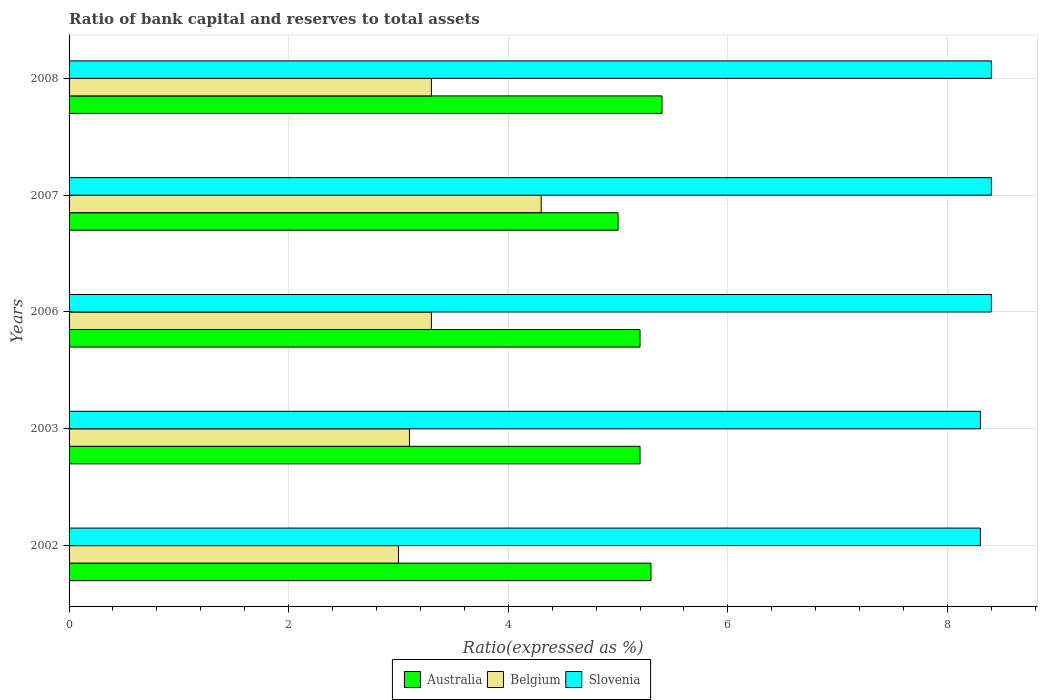How many groups of bars are there?
Provide a succinct answer. 5. Are the number of bars on each tick of the Y-axis equal?
Ensure brevity in your answer.  Yes. How many bars are there on the 3rd tick from the top?
Ensure brevity in your answer.  3. How many bars are there on the 1st tick from the bottom?
Your answer should be very brief. 3. What is the label of the 4th group of bars from the top?
Offer a terse response. 2003. Across all years, what is the maximum ratio of bank capital and reserves to total assets in Belgium?
Offer a terse response. 4.3. Across all years, what is the minimum ratio of bank capital and reserves to total assets in Belgium?
Your response must be concise. 3. In which year was the ratio of bank capital and reserves to total assets in Belgium maximum?
Give a very brief answer. 2007. What is the difference between the ratio of bank capital and reserves to total assets in Australia in 2002 and that in 2006?
Ensure brevity in your answer.  0.1. What is the difference between the ratio of bank capital and reserves to total assets in Slovenia in 2003 and the ratio of bank capital and reserves to total assets in Australia in 2002?
Ensure brevity in your answer.  3. What is the average ratio of bank capital and reserves to total assets in Australia per year?
Keep it short and to the point. 5.22. What is the ratio of the ratio of bank capital and reserves to total assets in Belgium in 2007 to that in 2008?
Provide a succinct answer. 1.3. What is the difference between the highest and the lowest ratio of bank capital and reserves to total assets in Australia?
Your answer should be very brief. 0.4. Is the sum of the ratio of bank capital and reserves to total assets in Belgium in 2003 and 2006 greater than the maximum ratio of bank capital and reserves to total assets in Slovenia across all years?
Your answer should be very brief. No. What does the 3rd bar from the top in 2006 represents?
Give a very brief answer. Australia. What does the 3rd bar from the bottom in 2007 represents?
Keep it short and to the point. Slovenia. How many bars are there?
Your answer should be compact. 15. Does the graph contain any zero values?
Your response must be concise. No. What is the title of the graph?
Your response must be concise. Ratio of bank capital and reserves to total assets. What is the label or title of the X-axis?
Make the answer very short. Ratio(expressed as %). What is the label or title of the Y-axis?
Ensure brevity in your answer.  Years. What is the Ratio(expressed as %) of Slovenia in 2002?
Your answer should be very brief. 8.3. What is the Ratio(expressed as %) of Australia in 2003?
Give a very brief answer. 5.2. What is the Ratio(expressed as %) in Belgium in 2003?
Ensure brevity in your answer.  3.1. What is the Ratio(expressed as %) in Slovenia in 2003?
Keep it short and to the point. 8.3. What is the Ratio(expressed as %) of Australia in 2006?
Offer a terse response. 5.2. What is the Ratio(expressed as %) of Slovenia in 2006?
Offer a very short reply. 8.4. What is the Ratio(expressed as %) of Australia in 2007?
Offer a terse response. 5. What is the Ratio(expressed as %) in Australia in 2008?
Provide a succinct answer. 5.4. What is the Ratio(expressed as %) in Slovenia in 2008?
Make the answer very short. 8.4. Across all years, what is the minimum Ratio(expressed as %) in Slovenia?
Keep it short and to the point. 8.3. What is the total Ratio(expressed as %) of Australia in the graph?
Your answer should be compact. 26.1. What is the total Ratio(expressed as %) in Belgium in the graph?
Offer a very short reply. 17. What is the total Ratio(expressed as %) of Slovenia in the graph?
Offer a terse response. 41.8. What is the difference between the Ratio(expressed as %) of Australia in 2002 and that in 2003?
Ensure brevity in your answer.  0.1. What is the difference between the Ratio(expressed as %) of Slovenia in 2002 and that in 2003?
Give a very brief answer. 0. What is the difference between the Ratio(expressed as %) of Belgium in 2002 and that in 2006?
Give a very brief answer. -0.3. What is the difference between the Ratio(expressed as %) of Slovenia in 2002 and that in 2006?
Offer a terse response. -0.1. What is the difference between the Ratio(expressed as %) in Australia in 2002 and that in 2007?
Your response must be concise. 0.3. What is the difference between the Ratio(expressed as %) of Belgium in 2002 and that in 2007?
Offer a terse response. -1.3. What is the difference between the Ratio(expressed as %) of Slovenia in 2002 and that in 2007?
Provide a short and direct response. -0.1. What is the difference between the Ratio(expressed as %) in Australia in 2002 and that in 2008?
Give a very brief answer. -0.1. What is the difference between the Ratio(expressed as %) in Australia in 2003 and that in 2006?
Your answer should be compact. 0. What is the difference between the Ratio(expressed as %) of Slovenia in 2003 and that in 2006?
Offer a terse response. -0.1. What is the difference between the Ratio(expressed as %) in Belgium in 2003 and that in 2007?
Make the answer very short. -1.2. What is the difference between the Ratio(expressed as %) in Belgium in 2003 and that in 2008?
Provide a succinct answer. -0.2. What is the difference between the Ratio(expressed as %) in Slovenia in 2003 and that in 2008?
Offer a very short reply. -0.1. What is the difference between the Ratio(expressed as %) of Belgium in 2006 and that in 2007?
Ensure brevity in your answer.  -1. What is the difference between the Ratio(expressed as %) of Slovenia in 2006 and that in 2008?
Make the answer very short. 0. What is the difference between the Ratio(expressed as %) of Belgium in 2007 and that in 2008?
Provide a short and direct response. 1. What is the difference between the Ratio(expressed as %) of Slovenia in 2007 and that in 2008?
Provide a short and direct response. 0. What is the difference between the Ratio(expressed as %) in Australia in 2002 and the Ratio(expressed as %) in Belgium in 2003?
Your response must be concise. 2.2. What is the difference between the Ratio(expressed as %) of Belgium in 2002 and the Ratio(expressed as %) of Slovenia in 2003?
Keep it short and to the point. -5.3. What is the difference between the Ratio(expressed as %) in Australia in 2002 and the Ratio(expressed as %) in Belgium in 2007?
Make the answer very short. 1. What is the difference between the Ratio(expressed as %) in Australia in 2002 and the Ratio(expressed as %) in Slovenia in 2007?
Give a very brief answer. -3.1. What is the difference between the Ratio(expressed as %) in Belgium in 2002 and the Ratio(expressed as %) in Slovenia in 2007?
Offer a very short reply. -5.4. What is the difference between the Ratio(expressed as %) of Australia in 2002 and the Ratio(expressed as %) of Slovenia in 2008?
Keep it short and to the point. -3.1. What is the difference between the Ratio(expressed as %) of Australia in 2003 and the Ratio(expressed as %) of Belgium in 2007?
Your response must be concise. 0.9. What is the difference between the Ratio(expressed as %) of Australia in 2003 and the Ratio(expressed as %) of Slovenia in 2008?
Provide a short and direct response. -3.2. What is the difference between the Ratio(expressed as %) in Australia in 2006 and the Ratio(expressed as %) in Belgium in 2007?
Your response must be concise. 0.9. What is the difference between the Ratio(expressed as %) in Australia in 2006 and the Ratio(expressed as %) in Belgium in 2008?
Offer a terse response. 1.9. What is the difference between the Ratio(expressed as %) of Belgium in 2006 and the Ratio(expressed as %) of Slovenia in 2008?
Provide a short and direct response. -5.1. What is the difference between the Ratio(expressed as %) of Australia in 2007 and the Ratio(expressed as %) of Belgium in 2008?
Ensure brevity in your answer.  1.7. What is the difference between the Ratio(expressed as %) in Belgium in 2007 and the Ratio(expressed as %) in Slovenia in 2008?
Your response must be concise. -4.1. What is the average Ratio(expressed as %) in Australia per year?
Ensure brevity in your answer.  5.22. What is the average Ratio(expressed as %) of Slovenia per year?
Ensure brevity in your answer.  8.36. In the year 2002, what is the difference between the Ratio(expressed as %) of Australia and Ratio(expressed as %) of Slovenia?
Keep it short and to the point. -3. In the year 2002, what is the difference between the Ratio(expressed as %) of Belgium and Ratio(expressed as %) of Slovenia?
Keep it short and to the point. -5.3. In the year 2003, what is the difference between the Ratio(expressed as %) of Australia and Ratio(expressed as %) of Belgium?
Provide a short and direct response. 2.1. In the year 2003, what is the difference between the Ratio(expressed as %) in Australia and Ratio(expressed as %) in Slovenia?
Offer a very short reply. -3.1. In the year 2006, what is the difference between the Ratio(expressed as %) of Australia and Ratio(expressed as %) of Belgium?
Offer a very short reply. 1.9. In the year 2006, what is the difference between the Ratio(expressed as %) in Australia and Ratio(expressed as %) in Slovenia?
Your response must be concise. -3.2. In the year 2007, what is the difference between the Ratio(expressed as %) of Belgium and Ratio(expressed as %) of Slovenia?
Offer a terse response. -4.1. In the year 2008, what is the difference between the Ratio(expressed as %) of Australia and Ratio(expressed as %) of Belgium?
Offer a very short reply. 2.1. In the year 2008, what is the difference between the Ratio(expressed as %) in Australia and Ratio(expressed as %) in Slovenia?
Offer a terse response. -3. In the year 2008, what is the difference between the Ratio(expressed as %) in Belgium and Ratio(expressed as %) in Slovenia?
Offer a very short reply. -5.1. What is the ratio of the Ratio(expressed as %) of Australia in 2002 to that in 2003?
Give a very brief answer. 1.02. What is the ratio of the Ratio(expressed as %) of Slovenia in 2002 to that in 2003?
Offer a terse response. 1. What is the ratio of the Ratio(expressed as %) of Australia in 2002 to that in 2006?
Your answer should be compact. 1.02. What is the ratio of the Ratio(expressed as %) in Slovenia in 2002 to that in 2006?
Give a very brief answer. 0.99. What is the ratio of the Ratio(expressed as %) of Australia in 2002 to that in 2007?
Your response must be concise. 1.06. What is the ratio of the Ratio(expressed as %) in Belgium in 2002 to that in 2007?
Offer a very short reply. 0.7. What is the ratio of the Ratio(expressed as %) in Australia in 2002 to that in 2008?
Your response must be concise. 0.98. What is the ratio of the Ratio(expressed as %) in Belgium in 2002 to that in 2008?
Your answer should be compact. 0.91. What is the ratio of the Ratio(expressed as %) in Belgium in 2003 to that in 2006?
Ensure brevity in your answer.  0.94. What is the ratio of the Ratio(expressed as %) of Belgium in 2003 to that in 2007?
Offer a terse response. 0.72. What is the ratio of the Ratio(expressed as %) of Belgium in 2003 to that in 2008?
Offer a very short reply. 0.94. What is the ratio of the Ratio(expressed as %) in Belgium in 2006 to that in 2007?
Your response must be concise. 0.77. What is the ratio of the Ratio(expressed as %) of Australia in 2007 to that in 2008?
Keep it short and to the point. 0.93. What is the ratio of the Ratio(expressed as %) in Belgium in 2007 to that in 2008?
Your answer should be very brief. 1.3. What is the ratio of the Ratio(expressed as %) in Slovenia in 2007 to that in 2008?
Provide a succinct answer. 1. What is the difference between the highest and the second highest Ratio(expressed as %) in Australia?
Your answer should be very brief. 0.1. 